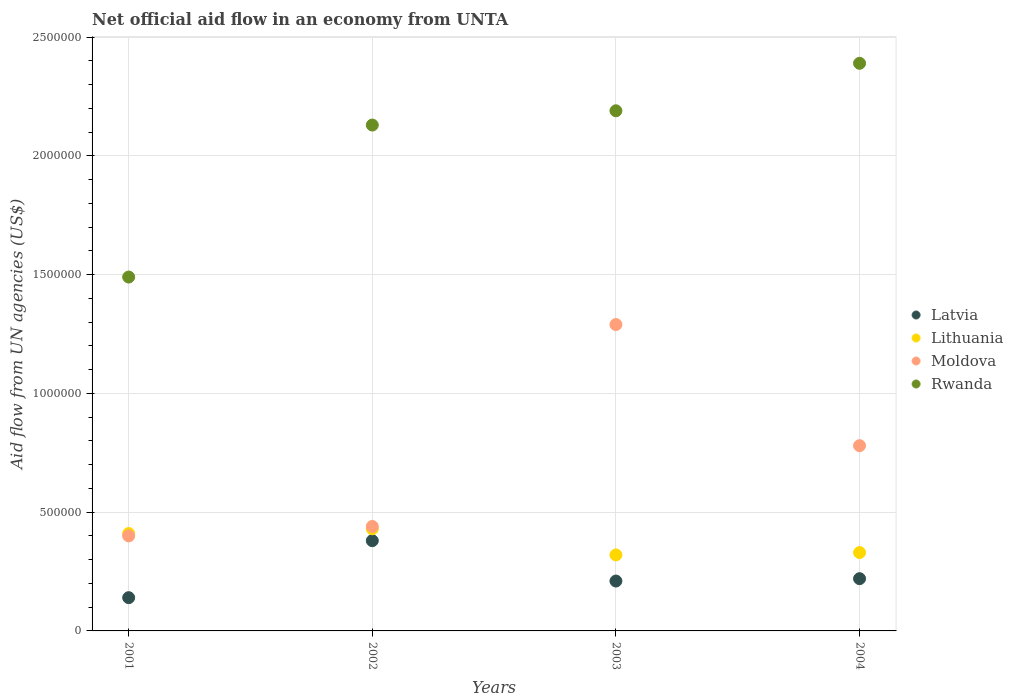Is the number of dotlines equal to the number of legend labels?
Your answer should be compact. Yes. What is the net official aid flow in Rwanda in 2002?
Your answer should be very brief. 2.13e+06. Across all years, what is the maximum net official aid flow in Latvia?
Offer a terse response. 3.80e+05. Across all years, what is the minimum net official aid flow in Moldova?
Your answer should be compact. 4.00e+05. In which year was the net official aid flow in Moldova maximum?
Provide a succinct answer. 2003. In which year was the net official aid flow in Rwanda minimum?
Your answer should be compact. 2001. What is the total net official aid flow in Latvia in the graph?
Make the answer very short. 9.50e+05. What is the difference between the net official aid flow in Latvia in 2004 and the net official aid flow in Rwanda in 2003?
Make the answer very short. -1.97e+06. What is the average net official aid flow in Lithuania per year?
Offer a very short reply. 3.72e+05. In the year 2003, what is the difference between the net official aid flow in Rwanda and net official aid flow in Lithuania?
Offer a very short reply. 1.87e+06. What is the ratio of the net official aid flow in Rwanda in 2001 to that in 2003?
Your answer should be compact. 0.68. Is the net official aid flow in Rwanda in 2001 less than that in 2002?
Your answer should be compact. Yes. Is the difference between the net official aid flow in Rwanda in 2001 and 2004 greater than the difference between the net official aid flow in Lithuania in 2001 and 2004?
Offer a very short reply. No. What is the difference between the highest and the lowest net official aid flow in Moldova?
Your response must be concise. 8.90e+05. Is it the case that in every year, the sum of the net official aid flow in Rwanda and net official aid flow in Moldova  is greater than the net official aid flow in Lithuania?
Your answer should be compact. Yes. Does the net official aid flow in Lithuania monotonically increase over the years?
Give a very brief answer. No. Is the net official aid flow in Rwanda strictly greater than the net official aid flow in Moldova over the years?
Provide a short and direct response. Yes. Is the net official aid flow in Moldova strictly less than the net official aid flow in Latvia over the years?
Offer a very short reply. No. How many dotlines are there?
Make the answer very short. 4. How many years are there in the graph?
Give a very brief answer. 4. What is the difference between two consecutive major ticks on the Y-axis?
Make the answer very short. 5.00e+05. Are the values on the major ticks of Y-axis written in scientific E-notation?
Your answer should be very brief. No. How many legend labels are there?
Provide a succinct answer. 4. How are the legend labels stacked?
Your answer should be compact. Vertical. What is the title of the graph?
Your answer should be very brief. Net official aid flow in an economy from UNTA. Does "Tajikistan" appear as one of the legend labels in the graph?
Provide a short and direct response. No. What is the label or title of the Y-axis?
Keep it short and to the point. Aid flow from UN agencies (US$). What is the Aid flow from UN agencies (US$) in Latvia in 2001?
Your answer should be compact. 1.40e+05. What is the Aid flow from UN agencies (US$) in Lithuania in 2001?
Make the answer very short. 4.10e+05. What is the Aid flow from UN agencies (US$) in Rwanda in 2001?
Give a very brief answer. 1.49e+06. What is the Aid flow from UN agencies (US$) of Lithuania in 2002?
Make the answer very short. 4.30e+05. What is the Aid flow from UN agencies (US$) of Rwanda in 2002?
Keep it short and to the point. 2.13e+06. What is the Aid flow from UN agencies (US$) of Moldova in 2003?
Keep it short and to the point. 1.29e+06. What is the Aid flow from UN agencies (US$) in Rwanda in 2003?
Ensure brevity in your answer.  2.19e+06. What is the Aid flow from UN agencies (US$) of Latvia in 2004?
Your answer should be very brief. 2.20e+05. What is the Aid flow from UN agencies (US$) in Moldova in 2004?
Provide a short and direct response. 7.80e+05. What is the Aid flow from UN agencies (US$) in Rwanda in 2004?
Keep it short and to the point. 2.39e+06. Across all years, what is the maximum Aid flow from UN agencies (US$) of Lithuania?
Provide a short and direct response. 4.30e+05. Across all years, what is the maximum Aid flow from UN agencies (US$) of Moldova?
Provide a succinct answer. 1.29e+06. Across all years, what is the maximum Aid flow from UN agencies (US$) in Rwanda?
Make the answer very short. 2.39e+06. Across all years, what is the minimum Aid flow from UN agencies (US$) of Rwanda?
Your response must be concise. 1.49e+06. What is the total Aid flow from UN agencies (US$) in Latvia in the graph?
Provide a short and direct response. 9.50e+05. What is the total Aid flow from UN agencies (US$) in Lithuania in the graph?
Offer a terse response. 1.49e+06. What is the total Aid flow from UN agencies (US$) in Moldova in the graph?
Offer a terse response. 2.91e+06. What is the total Aid flow from UN agencies (US$) in Rwanda in the graph?
Provide a succinct answer. 8.20e+06. What is the difference between the Aid flow from UN agencies (US$) of Latvia in 2001 and that in 2002?
Offer a terse response. -2.40e+05. What is the difference between the Aid flow from UN agencies (US$) in Rwanda in 2001 and that in 2002?
Ensure brevity in your answer.  -6.40e+05. What is the difference between the Aid flow from UN agencies (US$) in Moldova in 2001 and that in 2003?
Your answer should be very brief. -8.90e+05. What is the difference between the Aid flow from UN agencies (US$) of Rwanda in 2001 and that in 2003?
Keep it short and to the point. -7.00e+05. What is the difference between the Aid flow from UN agencies (US$) in Moldova in 2001 and that in 2004?
Give a very brief answer. -3.80e+05. What is the difference between the Aid flow from UN agencies (US$) in Rwanda in 2001 and that in 2004?
Your answer should be compact. -9.00e+05. What is the difference between the Aid flow from UN agencies (US$) of Moldova in 2002 and that in 2003?
Your answer should be compact. -8.50e+05. What is the difference between the Aid flow from UN agencies (US$) of Latvia in 2002 and that in 2004?
Provide a succinct answer. 1.60e+05. What is the difference between the Aid flow from UN agencies (US$) of Lithuania in 2002 and that in 2004?
Provide a short and direct response. 1.00e+05. What is the difference between the Aid flow from UN agencies (US$) of Moldova in 2002 and that in 2004?
Make the answer very short. -3.40e+05. What is the difference between the Aid flow from UN agencies (US$) in Rwanda in 2002 and that in 2004?
Offer a very short reply. -2.60e+05. What is the difference between the Aid flow from UN agencies (US$) of Moldova in 2003 and that in 2004?
Make the answer very short. 5.10e+05. What is the difference between the Aid flow from UN agencies (US$) in Rwanda in 2003 and that in 2004?
Provide a short and direct response. -2.00e+05. What is the difference between the Aid flow from UN agencies (US$) of Latvia in 2001 and the Aid flow from UN agencies (US$) of Lithuania in 2002?
Offer a terse response. -2.90e+05. What is the difference between the Aid flow from UN agencies (US$) in Latvia in 2001 and the Aid flow from UN agencies (US$) in Rwanda in 2002?
Provide a short and direct response. -1.99e+06. What is the difference between the Aid flow from UN agencies (US$) of Lithuania in 2001 and the Aid flow from UN agencies (US$) of Rwanda in 2002?
Your answer should be very brief. -1.72e+06. What is the difference between the Aid flow from UN agencies (US$) in Moldova in 2001 and the Aid flow from UN agencies (US$) in Rwanda in 2002?
Your answer should be compact. -1.73e+06. What is the difference between the Aid flow from UN agencies (US$) of Latvia in 2001 and the Aid flow from UN agencies (US$) of Moldova in 2003?
Your response must be concise. -1.15e+06. What is the difference between the Aid flow from UN agencies (US$) in Latvia in 2001 and the Aid flow from UN agencies (US$) in Rwanda in 2003?
Offer a terse response. -2.05e+06. What is the difference between the Aid flow from UN agencies (US$) in Lithuania in 2001 and the Aid flow from UN agencies (US$) in Moldova in 2003?
Offer a very short reply. -8.80e+05. What is the difference between the Aid flow from UN agencies (US$) in Lithuania in 2001 and the Aid flow from UN agencies (US$) in Rwanda in 2003?
Your answer should be very brief. -1.78e+06. What is the difference between the Aid flow from UN agencies (US$) in Moldova in 2001 and the Aid flow from UN agencies (US$) in Rwanda in 2003?
Your answer should be very brief. -1.79e+06. What is the difference between the Aid flow from UN agencies (US$) of Latvia in 2001 and the Aid flow from UN agencies (US$) of Moldova in 2004?
Give a very brief answer. -6.40e+05. What is the difference between the Aid flow from UN agencies (US$) of Latvia in 2001 and the Aid flow from UN agencies (US$) of Rwanda in 2004?
Provide a succinct answer. -2.25e+06. What is the difference between the Aid flow from UN agencies (US$) in Lithuania in 2001 and the Aid flow from UN agencies (US$) in Moldova in 2004?
Give a very brief answer. -3.70e+05. What is the difference between the Aid flow from UN agencies (US$) of Lithuania in 2001 and the Aid flow from UN agencies (US$) of Rwanda in 2004?
Offer a terse response. -1.98e+06. What is the difference between the Aid flow from UN agencies (US$) in Moldova in 2001 and the Aid flow from UN agencies (US$) in Rwanda in 2004?
Give a very brief answer. -1.99e+06. What is the difference between the Aid flow from UN agencies (US$) in Latvia in 2002 and the Aid flow from UN agencies (US$) in Moldova in 2003?
Offer a very short reply. -9.10e+05. What is the difference between the Aid flow from UN agencies (US$) of Latvia in 2002 and the Aid flow from UN agencies (US$) of Rwanda in 2003?
Offer a terse response. -1.81e+06. What is the difference between the Aid flow from UN agencies (US$) of Lithuania in 2002 and the Aid flow from UN agencies (US$) of Moldova in 2003?
Provide a succinct answer. -8.60e+05. What is the difference between the Aid flow from UN agencies (US$) of Lithuania in 2002 and the Aid flow from UN agencies (US$) of Rwanda in 2003?
Your answer should be very brief. -1.76e+06. What is the difference between the Aid flow from UN agencies (US$) in Moldova in 2002 and the Aid flow from UN agencies (US$) in Rwanda in 2003?
Your response must be concise. -1.75e+06. What is the difference between the Aid flow from UN agencies (US$) in Latvia in 2002 and the Aid flow from UN agencies (US$) in Lithuania in 2004?
Ensure brevity in your answer.  5.00e+04. What is the difference between the Aid flow from UN agencies (US$) of Latvia in 2002 and the Aid flow from UN agencies (US$) of Moldova in 2004?
Ensure brevity in your answer.  -4.00e+05. What is the difference between the Aid flow from UN agencies (US$) in Latvia in 2002 and the Aid flow from UN agencies (US$) in Rwanda in 2004?
Keep it short and to the point. -2.01e+06. What is the difference between the Aid flow from UN agencies (US$) in Lithuania in 2002 and the Aid flow from UN agencies (US$) in Moldova in 2004?
Offer a very short reply. -3.50e+05. What is the difference between the Aid flow from UN agencies (US$) in Lithuania in 2002 and the Aid flow from UN agencies (US$) in Rwanda in 2004?
Ensure brevity in your answer.  -1.96e+06. What is the difference between the Aid flow from UN agencies (US$) in Moldova in 2002 and the Aid flow from UN agencies (US$) in Rwanda in 2004?
Your answer should be very brief. -1.95e+06. What is the difference between the Aid flow from UN agencies (US$) in Latvia in 2003 and the Aid flow from UN agencies (US$) in Lithuania in 2004?
Ensure brevity in your answer.  -1.20e+05. What is the difference between the Aid flow from UN agencies (US$) of Latvia in 2003 and the Aid flow from UN agencies (US$) of Moldova in 2004?
Provide a short and direct response. -5.70e+05. What is the difference between the Aid flow from UN agencies (US$) in Latvia in 2003 and the Aid flow from UN agencies (US$) in Rwanda in 2004?
Keep it short and to the point. -2.18e+06. What is the difference between the Aid flow from UN agencies (US$) in Lithuania in 2003 and the Aid flow from UN agencies (US$) in Moldova in 2004?
Your response must be concise. -4.60e+05. What is the difference between the Aid flow from UN agencies (US$) in Lithuania in 2003 and the Aid flow from UN agencies (US$) in Rwanda in 2004?
Ensure brevity in your answer.  -2.07e+06. What is the difference between the Aid flow from UN agencies (US$) of Moldova in 2003 and the Aid flow from UN agencies (US$) of Rwanda in 2004?
Ensure brevity in your answer.  -1.10e+06. What is the average Aid flow from UN agencies (US$) of Latvia per year?
Your response must be concise. 2.38e+05. What is the average Aid flow from UN agencies (US$) of Lithuania per year?
Your answer should be very brief. 3.72e+05. What is the average Aid flow from UN agencies (US$) of Moldova per year?
Provide a succinct answer. 7.28e+05. What is the average Aid flow from UN agencies (US$) of Rwanda per year?
Your response must be concise. 2.05e+06. In the year 2001, what is the difference between the Aid flow from UN agencies (US$) in Latvia and Aid flow from UN agencies (US$) in Rwanda?
Keep it short and to the point. -1.35e+06. In the year 2001, what is the difference between the Aid flow from UN agencies (US$) of Lithuania and Aid flow from UN agencies (US$) of Moldova?
Keep it short and to the point. 10000. In the year 2001, what is the difference between the Aid flow from UN agencies (US$) of Lithuania and Aid flow from UN agencies (US$) of Rwanda?
Keep it short and to the point. -1.08e+06. In the year 2001, what is the difference between the Aid flow from UN agencies (US$) in Moldova and Aid flow from UN agencies (US$) in Rwanda?
Give a very brief answer. -1.09e+06. In the year 2002, what is the difference between the Aid flow from UN agencies (US$) in Latvia and Aid flow from UN agencies (US$) in Rwanda?
Offer a very short reply. -1.75e+06. In the year 2002, what is the difference between the Aid flow from UN agencies (US$) of Lithuania and Aid flow from UN agencies (US$) of Rwanda?
Your answer should be compact. -1.70e+06. In the year 2002, what is the difference between the Aid flow from UN agencies (US$) of Moldova and Aid flow from UN agencies (US$) of Rwanda?
Provide a succinct answer. -1.69e+06. In the year 2003, what is the difference between the Aid flow from UN agencies (US$) in Latvia and Aid flow from UN agencies (US$) in Lithuania?
Keep it short and to the point. -1.10e+05. In the year 2003, what is the difference between the Aid flow from UN agencies (US$) in Latvia and Aid flow from UN agencies (US$) in Moldova?
Ensure brevity in your answer.  -1.08e+06. In the year 2003, what is the difference between the Aid flow from UN agencies (US$) of Latvia and Aid flow from UN agencies (US$) of Rwanda?
Your response must be concise. -1.98e+06. In the year 2003, what is the difference between the Aid flow from UN agencies (US$) in Lithuania and Aid flow from UN agencies (US$) in Moldova?
Keep it short and to the point. -9.70e+05. In the year 2003, what is the difference between the Aid flow from UN agencies (US$) of Lithuania and Aid flow from UN agencies (US$) of Rwanda?
Make the answer very short. -1.87e+06. In the year 2003, what is the difference between the Aid flow from UN agencies (US$) of Moldova and Aid flow from UN agencies (US$) of Rwanda?
Your answer should be compact. -9.00e+05. In the year 2004, what is the difference between the Aid flow from UN agencies (US$) in Latvia and Aid flow from UN agencies (US$) in Moldova?
Your answer should be compact. -5.60e+05. In the year 2004, what is the difference between the Aid flow from UN agencies (US$) in Latvia and Aid flow from UN agencies (US$) in Rwanda?
Your response must be concise. -2.17e+06. In the year 2004, what is the difference between the Aid flow from UN agencies (US$) of Lithuania and Aid flow from UN agencies (US$) of Moldova?
Give a very brief answer. -4.50e+05. In the year 2004, what is the difference between the Aid flow from UN agencies (US$) in Lithuania and Aid flow from UN agencies (US$) in Rwanda?
Give a very brief answer. -2.06e+06. In the year 2004, what is the difference between the Aid flow from UN agencies (US$) of Moldova and Aid flow from UN agencies (US$) of Rwanda?
Offer a terse response. -1.61e+06. What is the ratio of the Aid flow from UN agencies (US$) in Latvia in 2001 to that in 2002?
Provide a succinct answer. 0.37. What is the ratio of the Aid flow from UN agencies (US$) in Lithuania in 2001 to that in 2002?
Make the answer very short. 0.95. What is the ratio of the Aid flow from UN agencies (US$) of Moldova in 2001 to that in 2002?
Offer a very short reply. 0.91. What is the ratio of the Aid flow from UN agencies (US$) of Rwanda in 2001 to that in 2002?
Keep it short and to the point. 0.7. What is the ratio of the Aid flow from UN agencies (US$) of Latvia in 2001 to that in 2003?
Provide a short and direct response. 0.67. What is the ratio of the Aid flow from UN agencies (US$) in Lithuania in 2001 to that in 2003?
Make the answer very short. 1.28. What is the ratio of the Aid flow from UN agencies (US$) of Moldova in 2001 to that in 2003?
Your answer should be very brief. 0.31. What is the ratio of the Aid flow from UN agencies (US$) of Rwanda in 2001 to that in 2003?
Provide a short and direct response. 0.68. What is the ratio of the Aid flow from UN agencies (US$) in Latvia in 2001 to that in 2004?
Make the answer very short. 0.64. What is the ratio of the Aid flow from UN agencies (US$) in Lithuania in 2001 to that in 2004?
Your response must be concise. 1.24. What is the ratio of the Aid flow from UN agencies (US$) in Moldova in 2001 to that in 2004?
Ensure brevity in your answer.  0.51. What is the ratio of the Aid flow from UN agencies (US$) of Rwanda in 2001 to that in 2004?
Provide a succinct answer. 0.62. What is the ratio of the Aid flow from UN agencies (US$) of Latvia in 2002 to that in 2003?
Make the answer very short. 1.81. What is the ratio of the Aid flow from UN agencies (US$) of Lithuania in 2002 to that in 2003?
Provide a succinct answer. 1.34. What is the ratio of the Aid flow from UN agencies (US$) of Moldova in 2002 to that in 2003?
Give a very brief answer. 0.34. What is the ratio of the Aid flow from UN agencies (US$) of Rwanda in 2002 to that in 2003?
Make the answer very short. 0.97. What is the ratio of the Aid flow from UN agencies (US$) in Latvia in 2002 to that in 2004?
Provide a succinct answer. 1.73. What is the ratio of the Aid flow from UN agencies (US$) in Lithuania in 2002 to that in 2004?
Your answer should be very brief. 1.3. What is the ratio of the Aid flow from UN agencies (US$) of Moldova in 2002 to that in 2004?
Make the answer very short. 0.56. What is the ratio of the Aid flow from UN agencies (US$) of Rwanda in 2002 to that in 2004?
Offer a terse response. 0.89. What is the ratio of the Aid flow from UN agencies (US$) of Latvia in 2003 to that in 2004?
Your response must be concise. 0.95. What is the ratio of the Aid flow from UN agencies (US$) of Lithuania in 2003 to that in 2004?
Ensure brevity in your answer.  0.97. What is the ratio of the Aid flow from UN agencies (US$) of Moldova in 2003 to that in 2004?
Your answer should be very brief. 1.65. What is the ratio of the Aid flow from UN agencies (US$) in Rwanda in 2003 to that in 2004?
Your response must be concise. 0.92. What is the difference between the highest and the second highest Aid flow from UN agencies (US$) in Moldova?
Provide a succinct answer. 5.10e+05. What is the difference between the highest and the lowest Aid flow from UN agencies (US$) of Lithuania?
Make the answer very short. 1.10e+05. What is the difference between the highest and the lowest Aid flow from UN agencies (US$) in Moldova?
Offer a terse response. 8.90e+05. What is the difference between the highest and the lowest Aid flow from UN agencies (US$) in Rwanda?
Your answer should be compact. 9.00e+05. 